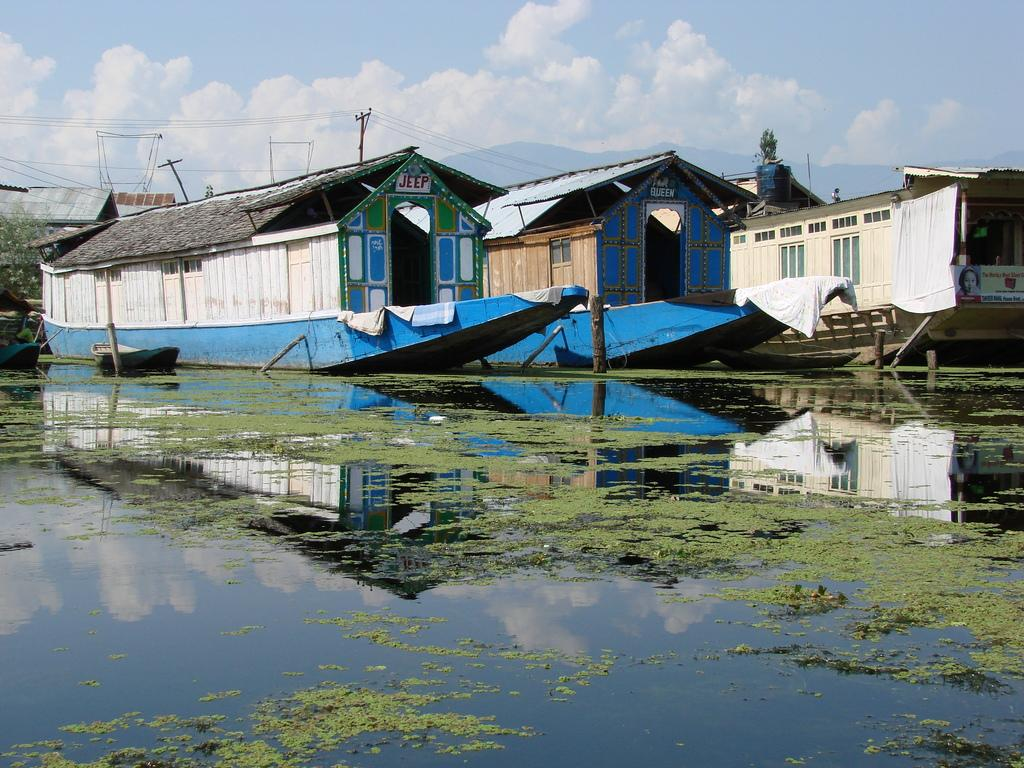What is at the bottom of the image? There is water at the bottom of the image. What structures can be seen in the middle of the image? There are boat houses in the middle of the image. What is visible at the top of the image? The sky is visible at the top of the image. How many bananas are hanging from the boat houses in the image? There are no bananas present in the image; it features water, boat houses, and the sky. What type of cracker is floating on the water in the image? There are no crackers present in the image; it only features water, boat houses, and the sky. 